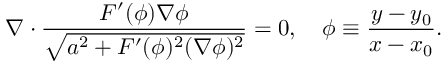<formula> <loc_0><loc_0><loc_500><loc_500>\nabla \cdot \frac { F ^ { \prime } ( \phi ) \nabla \phi } { \sqrt { a ^ { 2 } + F ^ { \prime } ( \phi ) ^ { 2 } ( \nabla \phi ) ^ { 2 } } } = 0 , \phi \equiv \frac { y - y _ { 0 } } { x - x _ { 0 } } .</formula> 